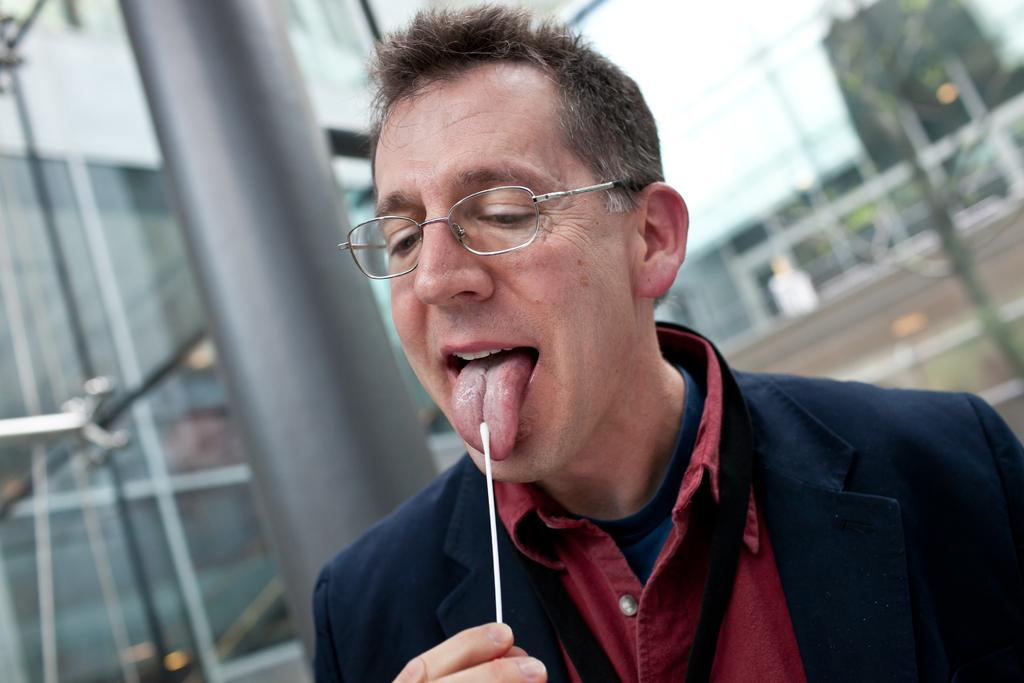Who is present in the image? There is a man in the image. What is the man wearing? The man is wearing clothes and spectacles. What is the man holding in his hand? The man is holding a stick in his hand. What can be seen in the background of the image? There is a glass construction in the background of the image. How would you describe the background of the image? The background of the image is blurred. What type of salt is being used by the giants in the image? There are no giants or salt present in the image. What is the man doing at the hospital in the image? There is no hospital or indication of the man being at a hospital in the image. 